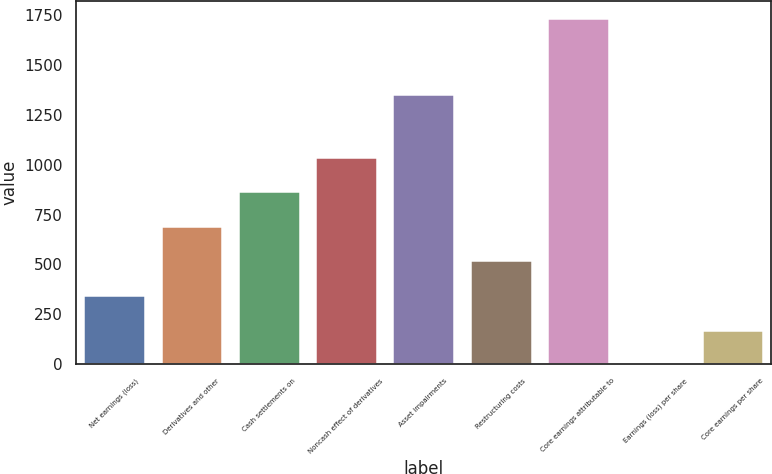Convert chart. <chart><loc_0><loc_0><loc_500><loc_500><bar_chart><fcel>Net earnings (loss)<fcel>Derivatives and other<fcel>Cash settlements on<fcel>Noncash effect of derivatives<fcel>Asset impairments<fcel>Restructuring costs<fcel>Core earnings attributable to<fcel>Earnings (loss) per share<fcel>Core earnings per share<nl><fcel>346.84<fcel>693.62<fcel>867.01<fcel>1040.4<fcel>1353<fcel>520.23<fcel>1734<fcel>0.06<fcel>173.45<nl></chart> 